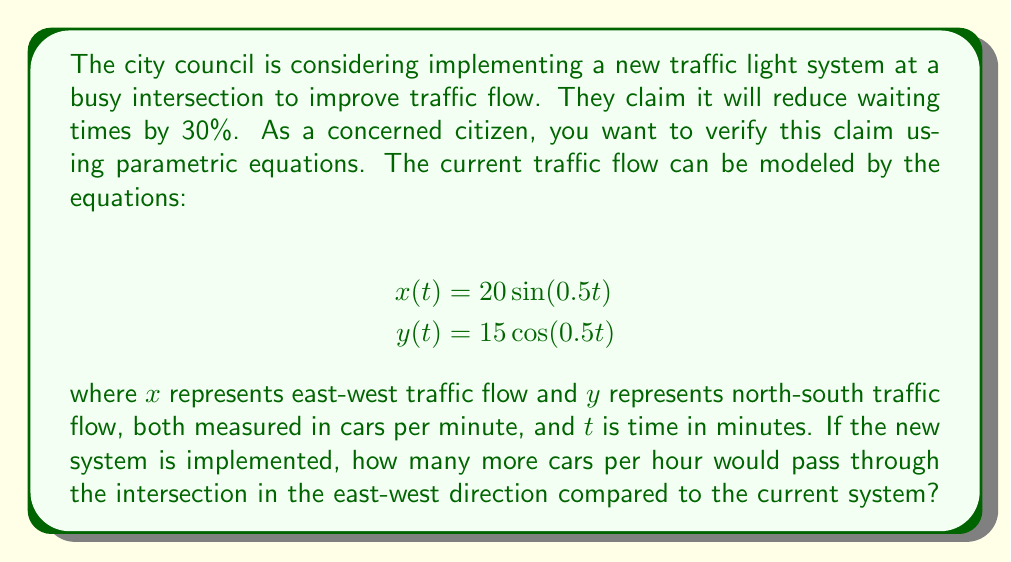Solve this math problem. To solve this problem, we need to follow these steps:

1. Calculate the current number of cars passing through the intersection in the east-west direction per hour.
2. Calculate the number of cars that would pass through with the claimed 30% improvement.
3. Find the difference between these two values.

Step 1: Current traffic flow
The east-west traffic flow is represented by $x(t) = 20\sin(0.5t)$. To find the total number of cars passing through in an hour, we need to integrate this function over one full cycle and multiply by the number of cycles in an hour.

Period of the function: $T = \frac{2\pi}{0.5} = 4\pi$ minutes

Number of cycles in an hour: $\frac{60}{4\pi}$

Cars per cycle: 
$$\int_0^{4\pi} 20\sin(0.5t) dt = -40\cos(0.5t)\Big|_0^{4\pi} = 80$$

Cars per hour: $80 \cdot \frac{60}{4\pi} = \frac{1200}{\pi} \approx 382$ cars

Step 2: Improved traffic flow
With a 30% improvement, the new number of cars per hour would be:

$$\frac{1200}{\pi} \cdot 1.3 = \frac{1560}{\pi} \approx 497$$ cars

Step 3: Difference
The difference in cars per hour:

$$\frac{1560}{\pi} - \frac{1200}{\pi} = \frac{360}{\pi} \approx 115$$ cars
Answer: Approximately 115 more cars per hour would pass through the intersection in the east-west direction with the new system. 